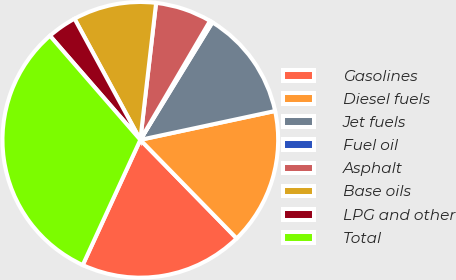Convert chart to OTSL. <chart><loc_0><loc_0><loc_500><loc_500><pie_chart><fcel>Gasolines<fcel>Diesel fuels<fcel>Jet fuels<fcel>Fuel oil<fcel>Asphalt<fcel>Base oils<fcel>LPG and other<fcel>Total<nl><fcel>19.18%<fcel>16.04%<fcel>12.89%<fcel>0.32%<fcel>6.61%<fcel>9.75%<fcel>3.46%<fcel>31.76%<nl></chart> 